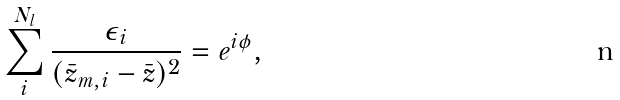Convert formula to latex. <formula><loc_0><loc_0><loc_500><loc_500>\sum _ { i } ^ { N _ { l } } \frac { \epsilon _ { i } } { ( { \bar { z } } _ { m , i } - { \bar { z } } ) ^ { 2 } } = e ^ { i \phi } ,</formula> 